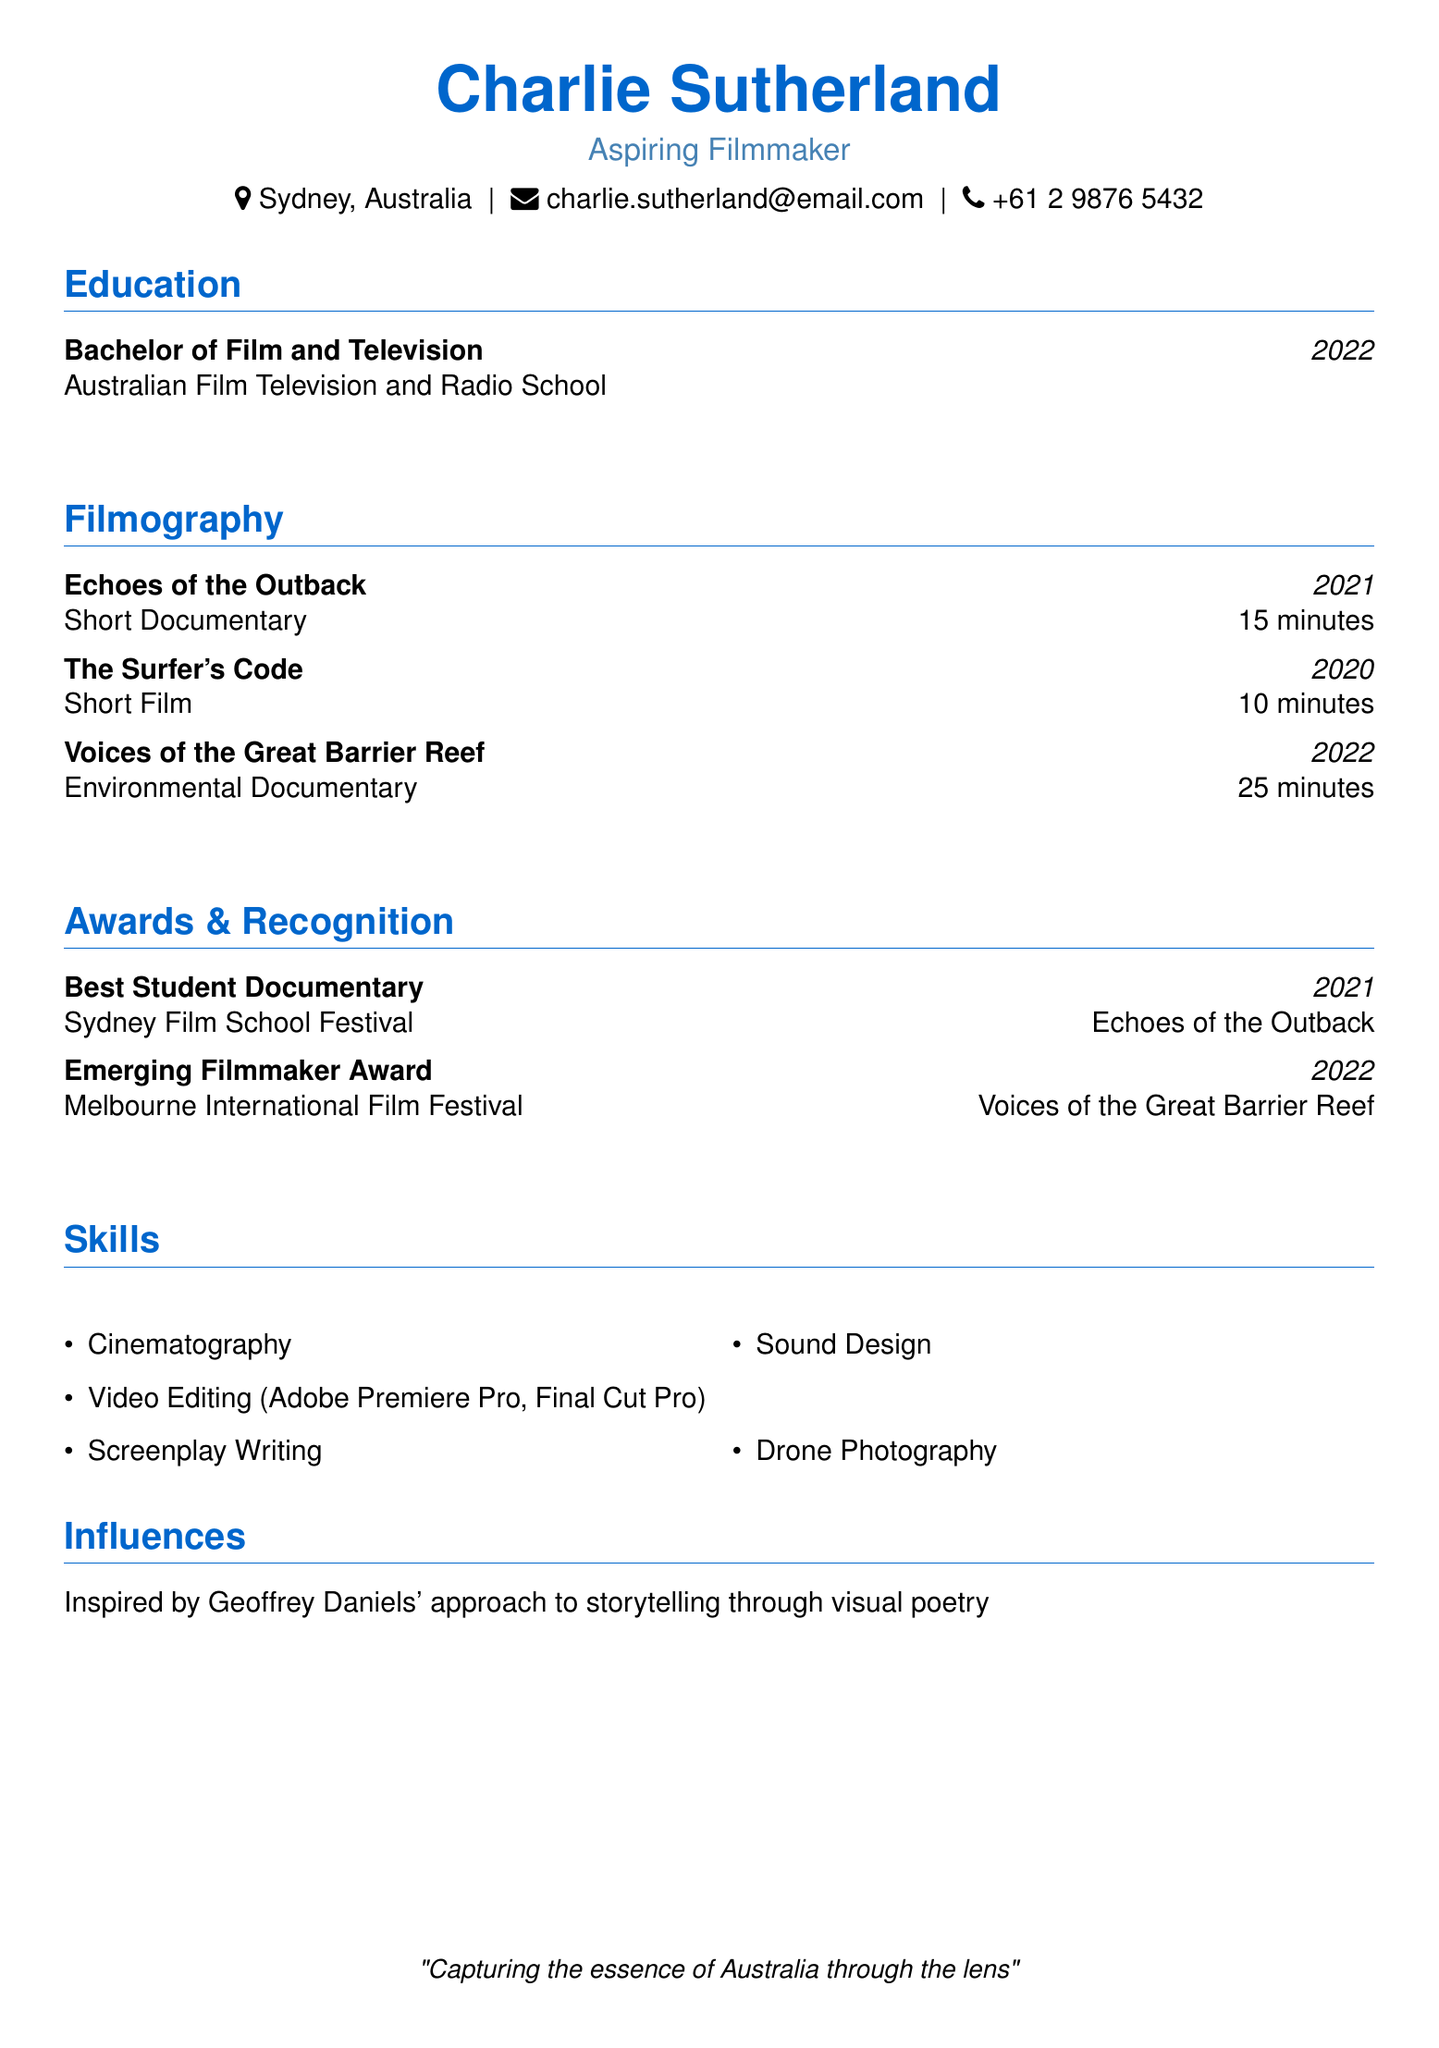What is Charlie Sutherland's location? The document states that Charlie is located in Sydney, Australia.
Answer: Sydney, Australia What degree did Charlie Sutherland earn? The education section lists Charlie's degree as Bachelor of Film and Television.
Answer: Bachelor of Film and Television What is the title of the short film released in 2020? The filmography section indicates that the title of the short film from 2020 is "The Surfer's Code".
Answer: The Surfer's Code How many awards did Charlie receive in 2022? The awards and recognition section shows two awards are received in separate years; one awards in 2022 and another in 2021.
Answer: One What is the total duration of "Voices of the Great Barrier Reef"? The filmography section lists the duration of "Voices of the Great Barrier Reef" as 25 minutes.
Answer: 25 minutes Who is an influential filmmaker mentioned in the document? The influences section states that Charlie admires Geoffrey Daniels.
Answer: Geoffrey Daniels What skill does Charlie possess related to video editing? The skills section includes "Video Editing (Adobe Premiere Pro, Final Cut Pro)," indicating capability in those programs.
Answer: Video Editing (Adobe Premiere Pro, Final Cut Pro) At which event did Charlie win the Best Student Documentary award? The awards section specifies that the Best Student Documentary was awarded at the Sydney Film School Festival.
Answer: Sydney Film School Festival How long is "Echoes of the Outback" as stated in the filmography? The filmography lists the duration of "Echoes of the Outback" as 15 minutes.
Answer: 15 minutes 